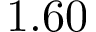Convert formula to latex. <formula><loc_0><loc_0><loc_500><loc_500>1 . 6 0</formula> 